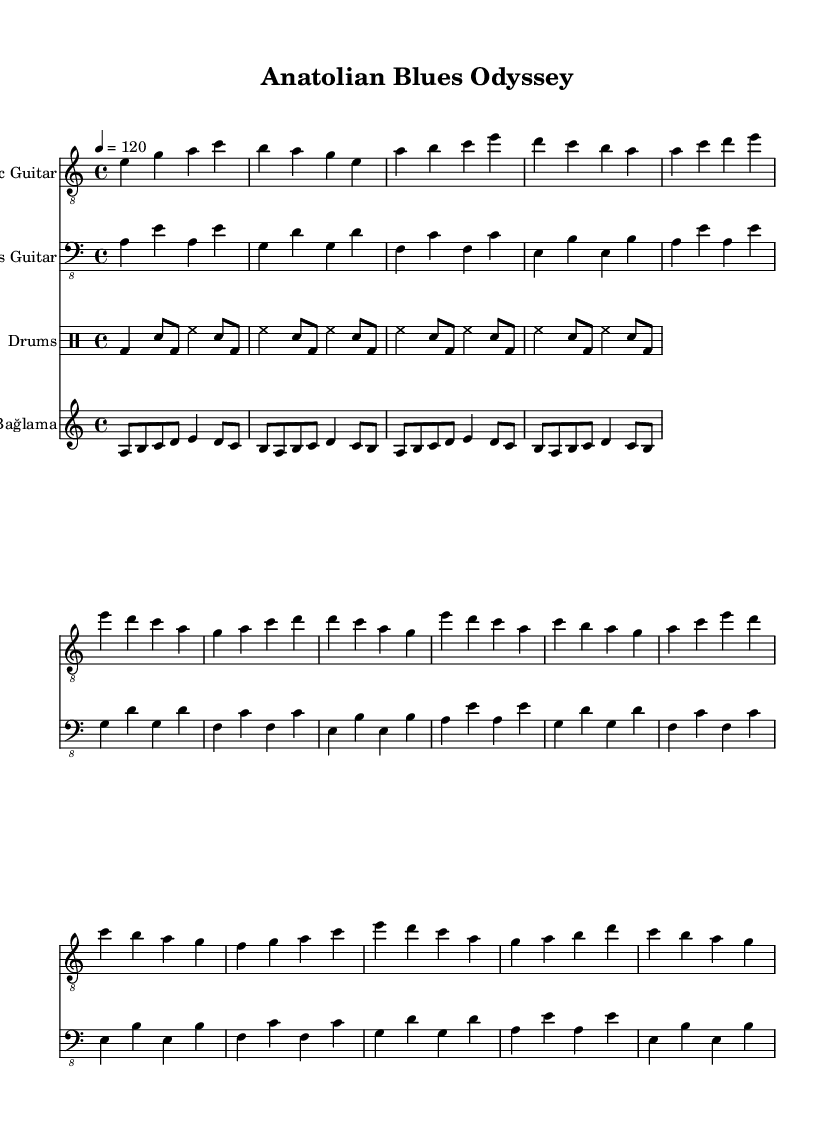What is the key signature of this music? The key signature indicates that the piece is in A minor, which contains no sharps or flats. This can be identified by looking at the initial part of the score where the key signature is placed.
Answer: A minor What is the time signature of this music? The time signature is 4/4, meaning there are four beats in each measure and the quarter note gets one beat. This can be found in the beginning of the score where it is clearly marked.
Answer: 4/4 What is the tempo marking for this music? The tempo marking indicates that the piece should be played at a speed of 120 beats per minute. This is typically found at the beginning of the score under the header.
Answer: 120 How many measures are used in the verse section? The verse section contains four measures based on the provided melodic material. By counting the sets of bars within the verse section, you can confirm this.
Answer: Four measures What instruments are featured in this composition? The composition features four instruments: Electric Guitar, Bass Guitar, Drums, and Bağlama. This information is at the start of each staff in the score, which labels them accordingly.
Answer: Electric Guitar, Bass Guitar, Drums, Bağlama Is there a dominant seven chord in the piece? Yes, in the context of the A minor key, the dominant seven chord, which is E7, can be observed. Analyzing the chords used in the piece and comparing them to the A minor scale reveals this dominant seven chord.
Answer: E7 What type of rhythm pattern is used in the drums? The drums part uses a basic blues shuffle pattern, which is characteristic of electric blues music. This can be recognized by the rhythmic structure indicated in the drum notation throughout the score.
Answer: Blues shuffle 